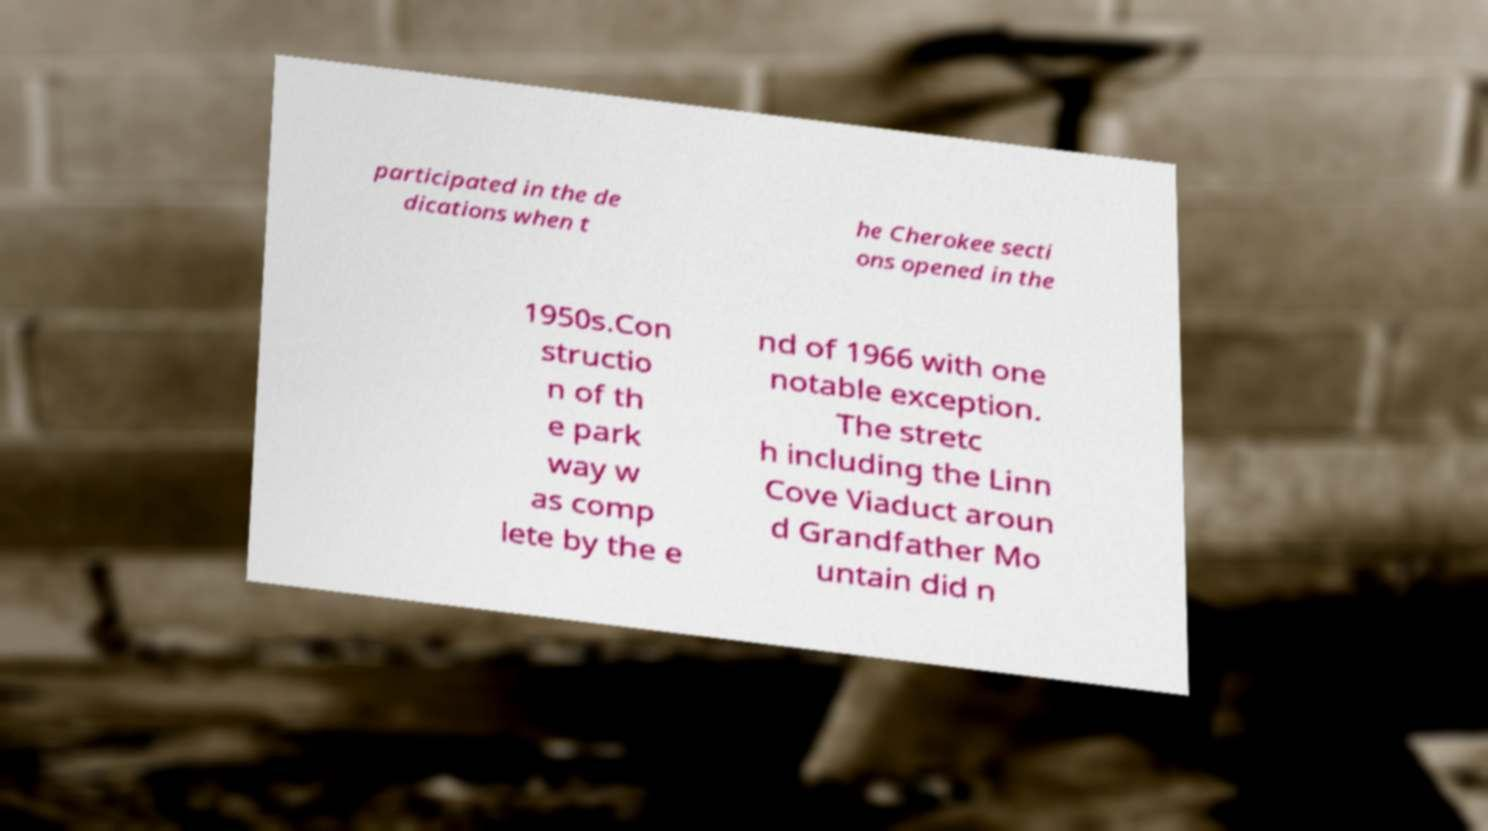What messages or text are displayed in this image? I need them in a readable, typed format. participated in the de dications when t he Cherokee secti ons opened in the 1950s.Con structio n of th e park way w as comp lete by the e nd of 1966 with one notable exception. The stretc h including the Linn Cove Viaduct aroun d Grandfather Mo untain did n 